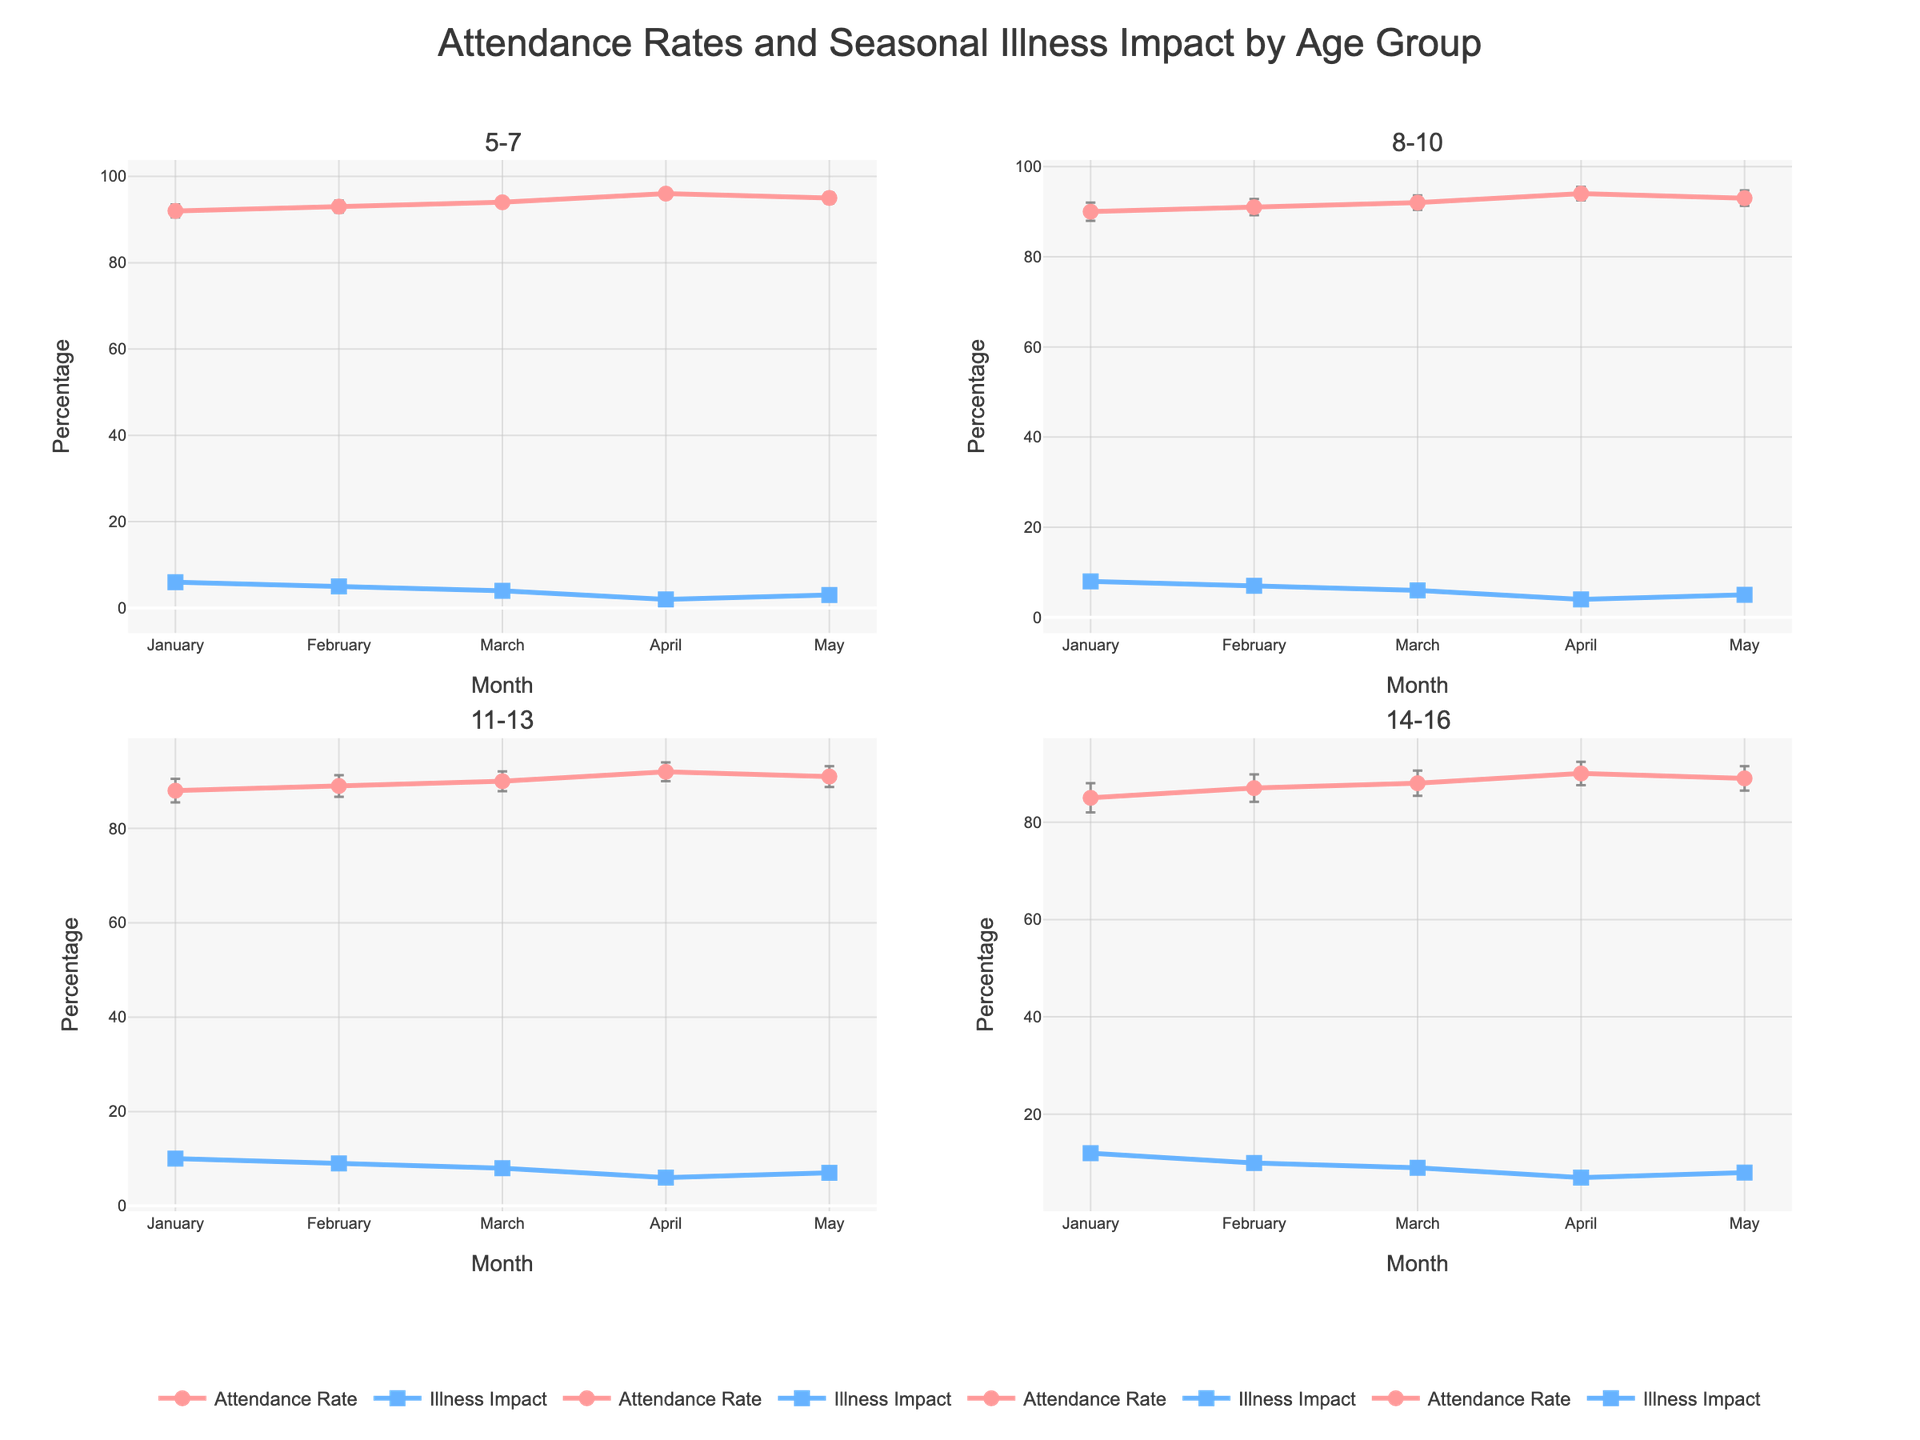What's the average attendance rate for the 11-13 age group in January? Locate the 11-13 age group subplot and observe the data point for January, which indicates the average attendance rate.
Answer: 88 What is the standard error for the 5-7 age group in March? Locate the 5-7 age group subplot and refer to the error bars for March. The length of the error bar corresponds to the standard error.
Answer: 1.2 In which month does the 8-10 age group have the highest attendance rate? Find the 8-10 age group subplot and compare the attendance rates across all months. Look for the highest data point.
Answer: April By how much does the seasonal illness impact for the 14-16 age group decrease from January to February? Identify the 14-16 age group subplot, note the seasonal illness impact for January and February, and subtract the February value from the January value.
Answer: 2 Which age group has the smallest standard error in May? Check the subplots for all age groups and compare the standard errors for May. The shortest error bar corresponds to the smallest standard error.
Answer: 5-7 How does the average attendance rate change from January to May for the 5-7 age group? Observe the 5-7 age group subplot, note the average attendance rates for January and May, and calculate the difference.
Answer: Increases by 3 Compare the illness impact in March between 8-10 and 11-13 age groups and determine which group has a higher value. Examine the March data for both the 8-10 and 11-13 subplots and compare the seasonal illness impact values.
Answer: 11-13 What is the relationship between average attendance rates and seasonal illness impact across all age groups? Across all subplots, look for trends or patterns showing how changes in seasonal illness impact correlate with changes in attendance rates. Typically, higher illness impact corresponds to lower attendance rates and vice versa.
Answer: Inversely related 